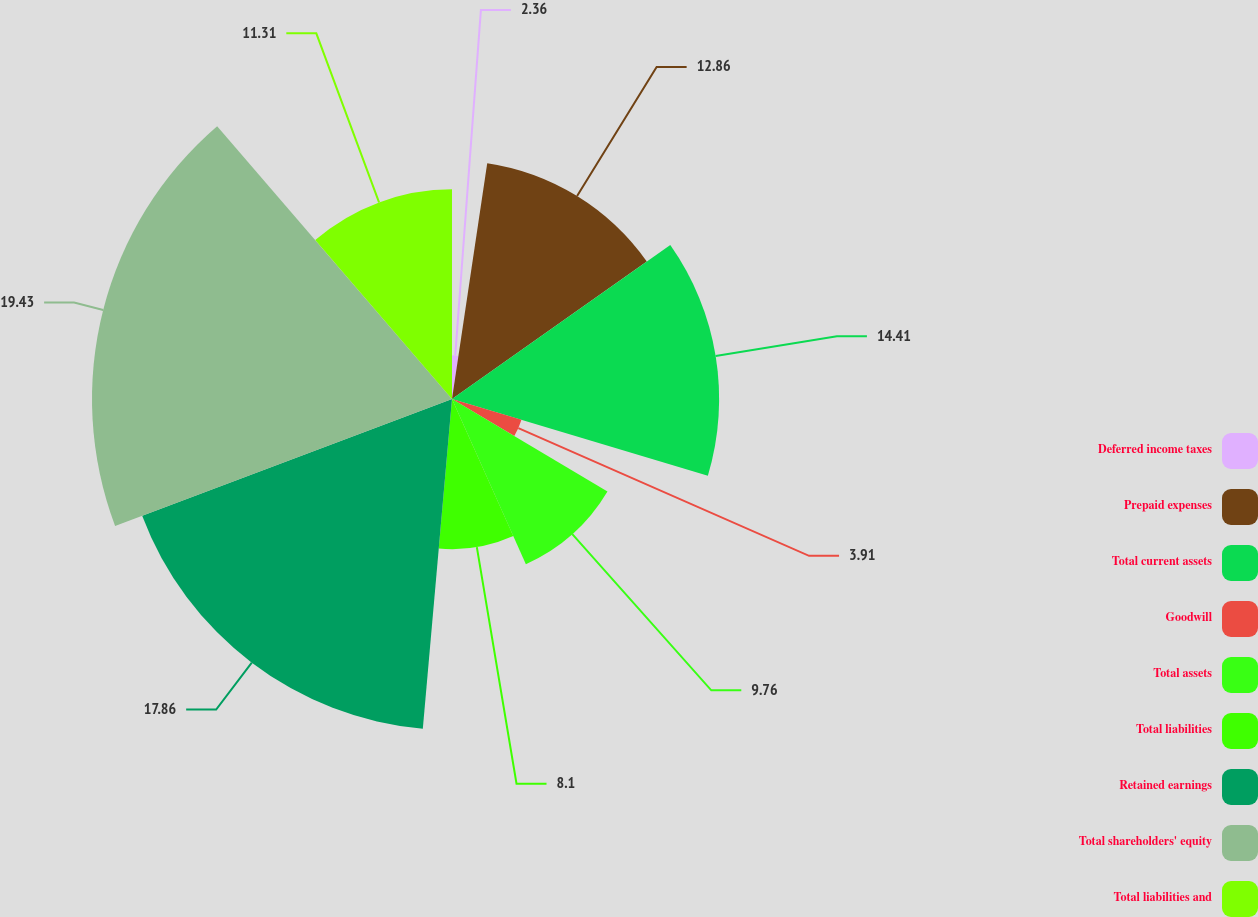Convert chart. <chart><loc_0><loc_0><loc_500><loc_500><pie_chart><fcel>Deferred income taxes<fcel>Prepaid expenses<fcel>Total current assets<fcel>Goodwill<fcel>Total assets<fcel>Total liabilities<fcel>Retained earnings<fcel>Total shareholders' equity<fcel>Total liabilities and<nl><fcel>2.36%<fcel>12.86%<fcel>14.41%<fcel>3.91%<fcel>9.76%<fcel>8.1%<fcel>17.86%<fcel>19.42%<fcel>11.31%<nl></chart> 